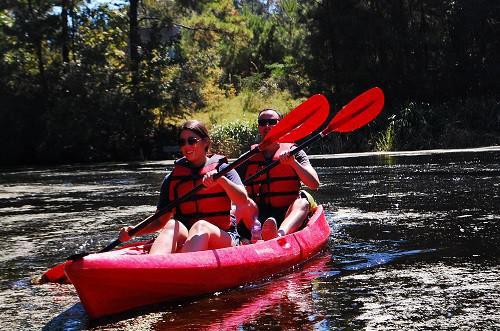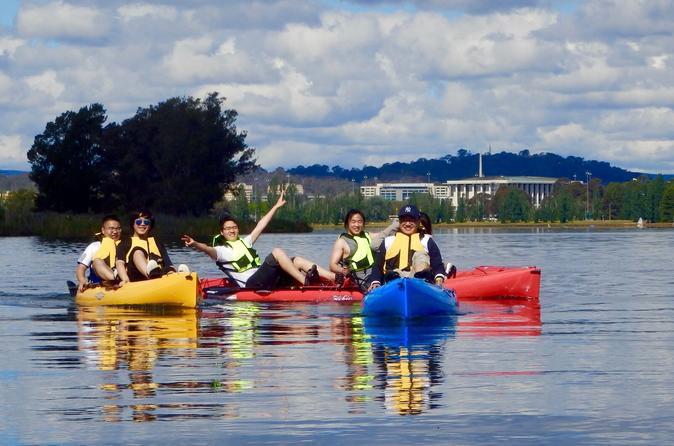The first image is the image on the left, the second image is the image on the right. Examine the images to the left and right. Is the description "There is exactly one boat in the left image." accurate? Answer yes or no. Yes. The first image is the image on the left, the second image is the image on the right. Considering the images on both sides, is "Each image includes at least one person in a canoe on water, with the boat aimed forward." valid? Answer yes or no. Yes. 